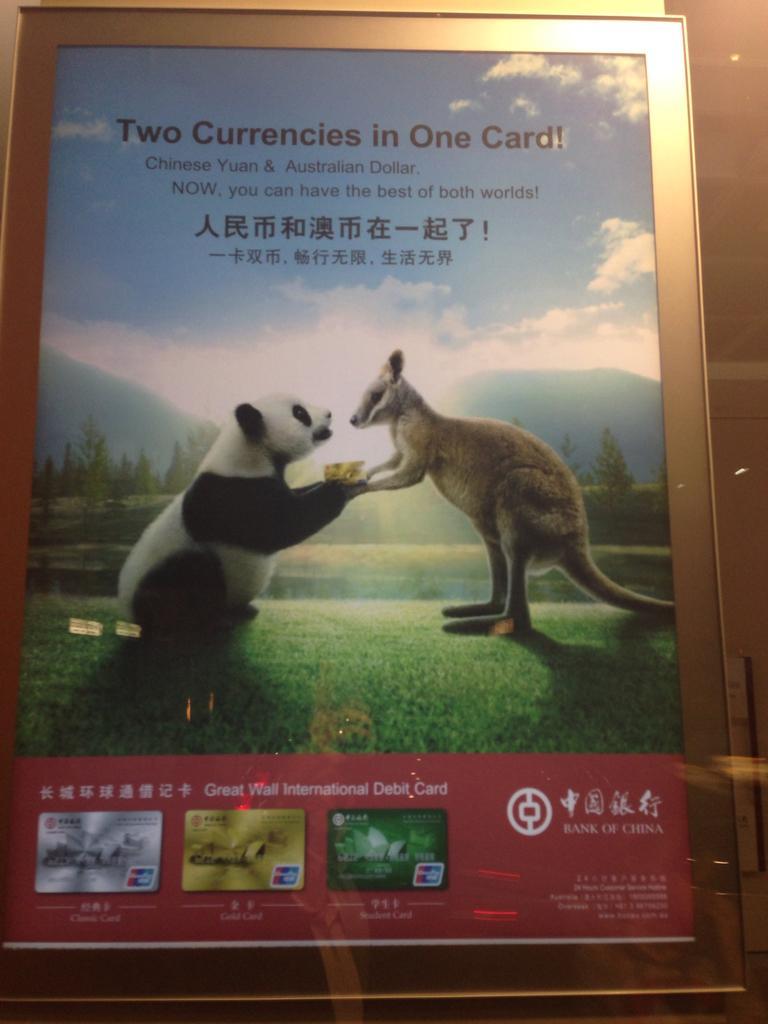Describe this image in one or two sentences. In this picture we can see a board on the wall, lights. On the board we can see the text and pictures. 